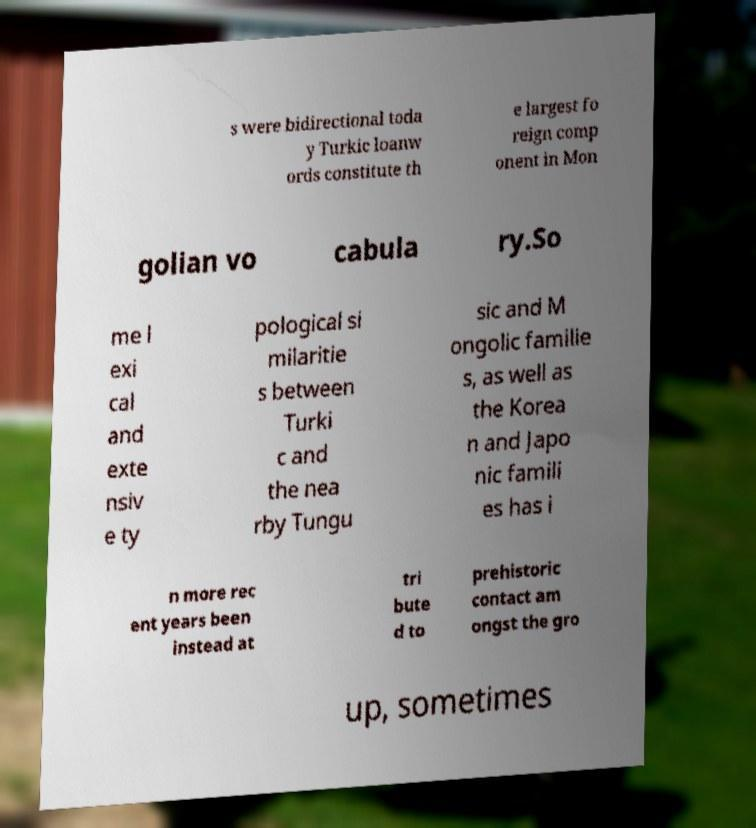For documentation purposes, I need the text within this image transcribed. Could you provide that? s were bidirectional toda y Turkic loanw ords constitute th e largest fo reign comp onent in Mon golian vo cabula ry.So me l exi cal and exte nsiv e ty pological si milaritie s between Turki c and the nea rby Tungu sic and M ongolic familie s, as well as the Korea n and Japo nic famili es has i n more rec ent years been instead at tri bute d to prehistoric contact am ongst the gro up, sometimes 